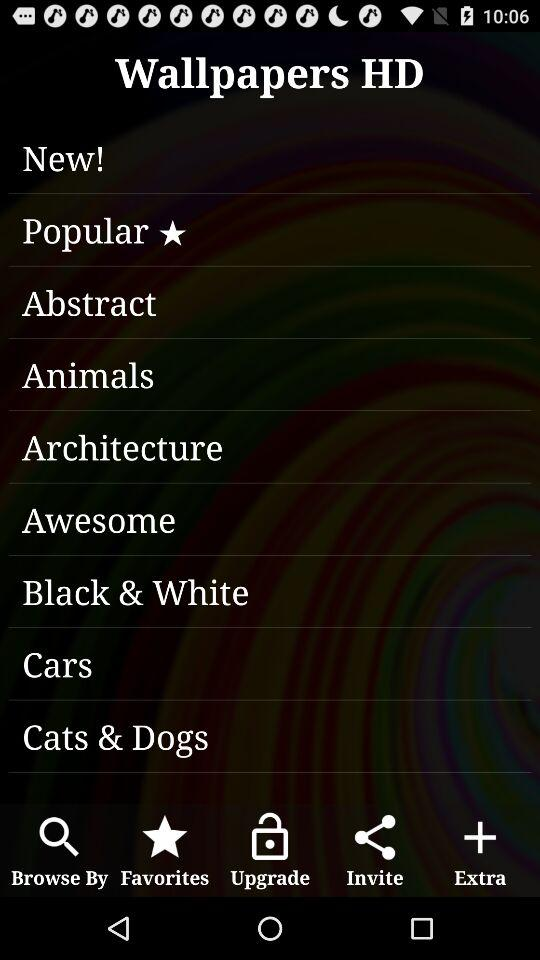What is the application name? The application name is "Wallpapers HD". 